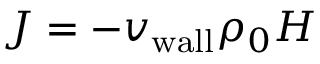<formula> <loc_0><loc_0><loc_500><loc_500>J = - { v _ { w a l l } } \rho _ { 0 } H</formula> 